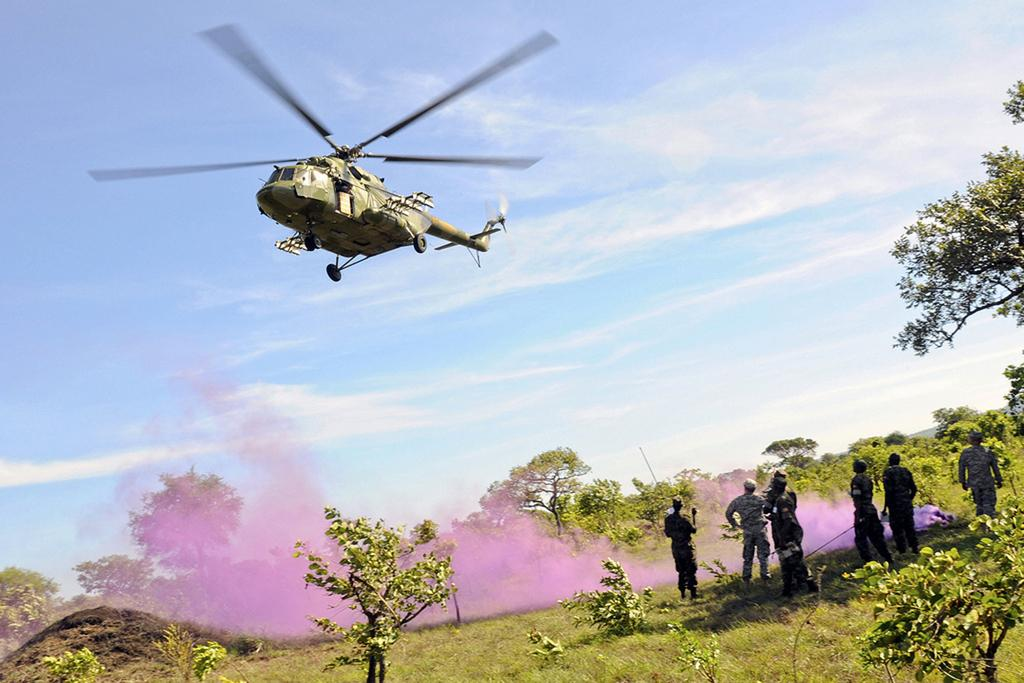What is flying in the air in the image? There is a helicopter in the air in the image. What can be seen at the bottom of the image? There are trees, plants, grass, people, and smoke at the bottom of the image. What is visible in the background of the image? The sky is visible in the background of the image. What type of jeans are the people wearing in the image? There is no information about the type of jeans the people are wearing in the image, as the focus is on the helicopter and the elements at the bottom of the image. 